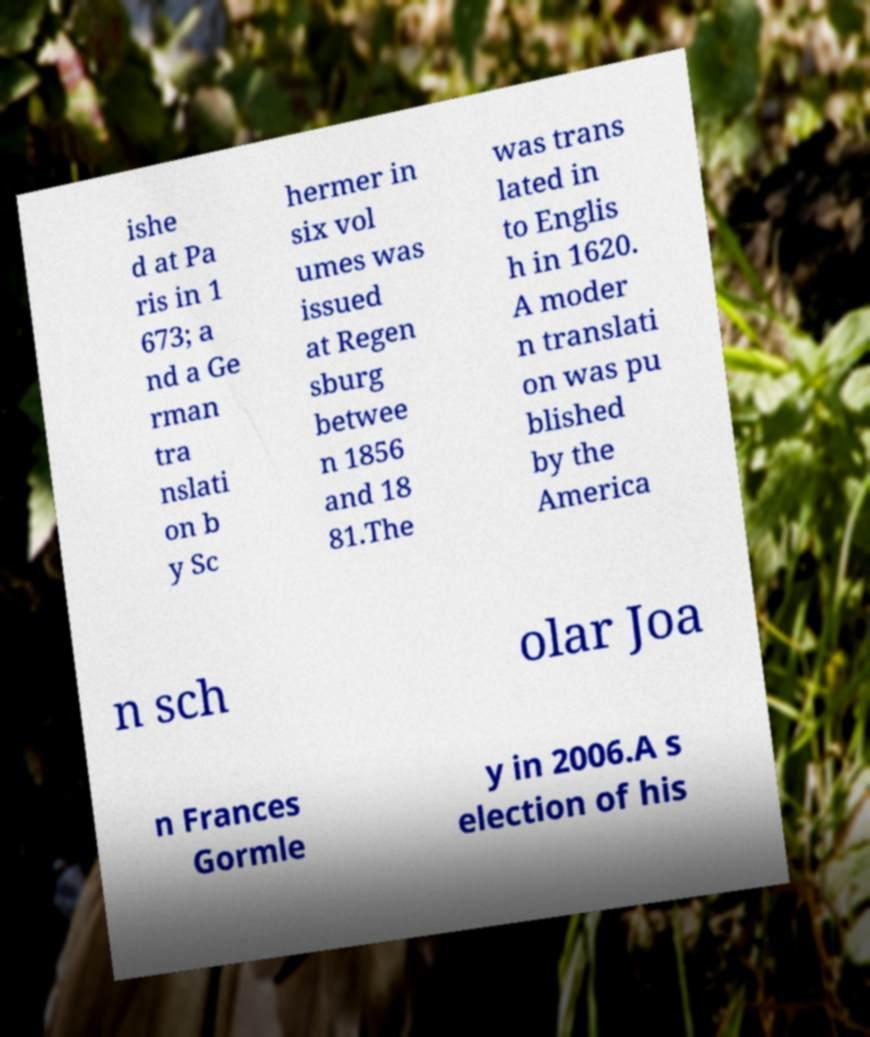Please identify and transcribe the text found in this image. ishe d at Pa ris in 1 673; a nd a Ge rman tra nslati on b y Sc hermer in six vol umes was issued at Regen sburg betwee n 1856 and 18 81.The was trans lated in to Englis h in 1620. A moder n translati on was pu blished by the America n sch olar Joa n Frances Gormle y in 2006.A s election of his 